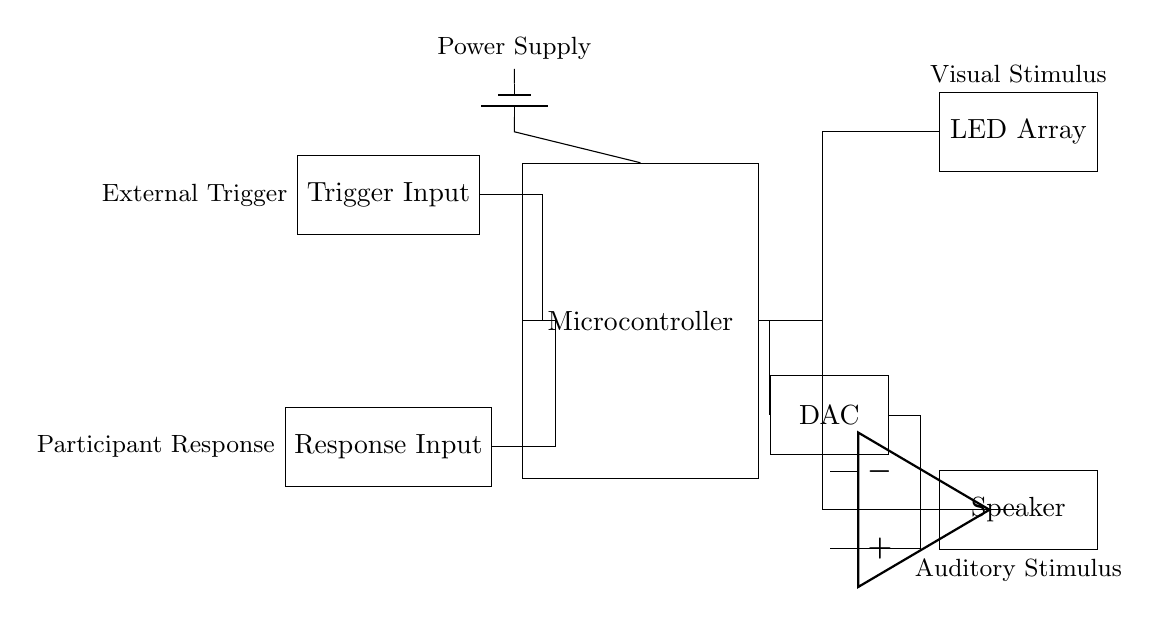What component is responsible for visual stimulus? The LED array is specifically designated in the circuit for providing visual stimulus to the participants. It is connected to the microcontroller, indicating its role in the system for visual feedback.
Answer: LED Array What is the main function of the microcontroller? The microcontroller serves as the control unit that manages inputs from the trigger and response as well as outputs to the LED array and speaker. It processes and determines the timing of visual and auditory cues in the experiment.
Answer: Control Unit How many input components are present in the circuit? There are two input components in the circuit: the trigger input for initiating the experiment and the response input for capturing participant responses. Both are connected to the microcontroller for processing.
Answer: Two What type of amplifier is used in the circuit? An operational amplifier is utilized in the circuit for amplifying the audio signal before sending it to the speaker, ensuring clear auditory stimuli for the participants.
Answer: Operational Amplifier What triggers the microcontroller in this circuit? The microcontroller is triggered by an external trigger input, which signifies when to start the presentation of stimuli based on the experimental design. This input connects directly to the microcontroller.
Answer: External Trigger Input What type of stimulus is provided by the speaker? The speaker provides auditory stimuli, which are essential for facilitating sound cues in psychological experiments. This is controlled through the microcontroller and amplified before output.
Answer: Auditory Stimulus What is the role of the DAC in this circuit? The Digital-to-Analog Converter (DAC) translates digital signals from the microcontroller into analog signals, which can then be processed by the amplifier for auditory output, thereby bridging digital control and analog performance.
Answer: Digital-to-Analog Converter 